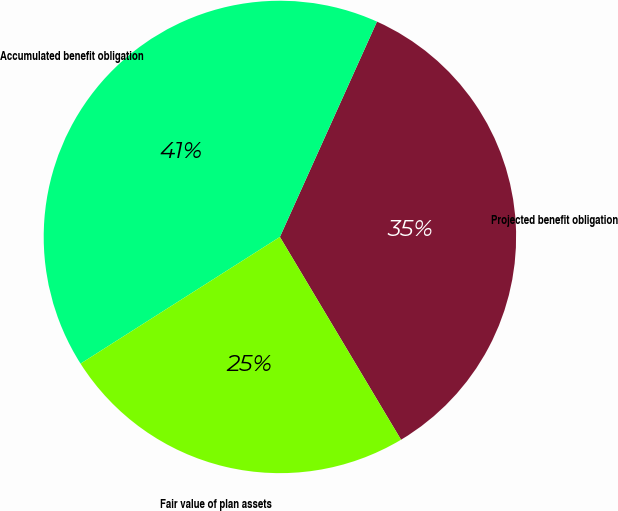<chart> <loc_0><loc_0><loc_500><loc_500><pie_chart><fcel>Projected benefit obligation<fcel>Accumulated benefit obligation<fcel>Fair value of plan assets<nl><fcel>34.69%<fcel>40.75%<fcel>24.56%<nl></chart> 